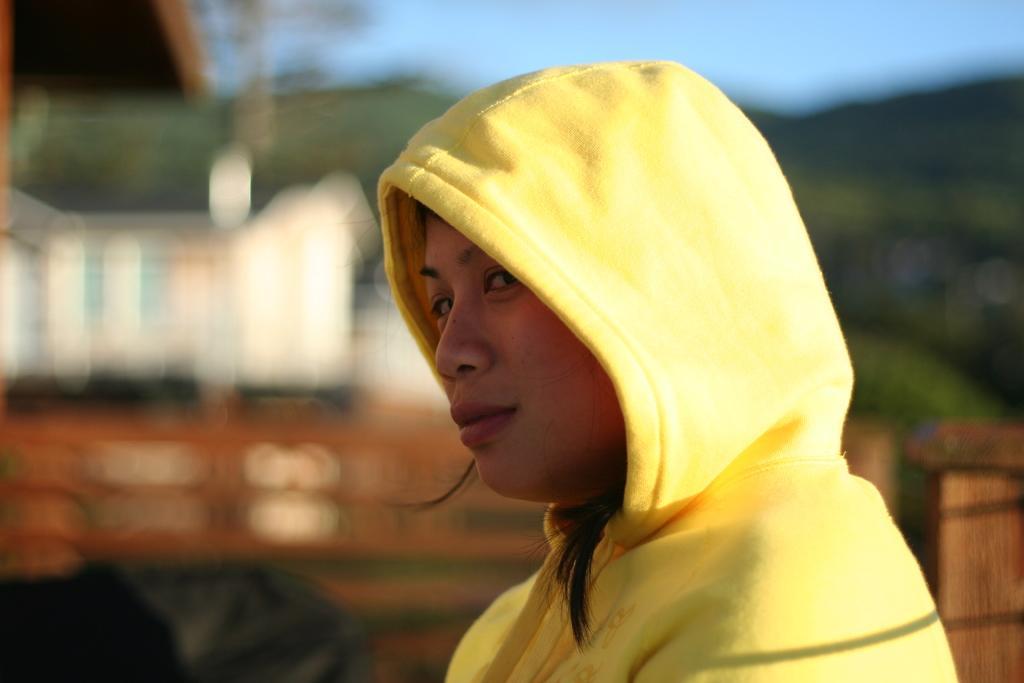Please provide a concise description of this image. In this picture I can observe a woman in the middle of the picture. She is wearing yellow color hoodie. The background is blurred. 